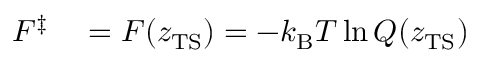Convert formula to latex. <formula><loc_0><loc_0><loc_500><loc_500>\begin{array} { r l } { F ^ { \ddagger } } & = F ( z _ { T S } ) = - k _ { B } T \ln Q ( z _ { T S } ) } \end{array}</formula> 